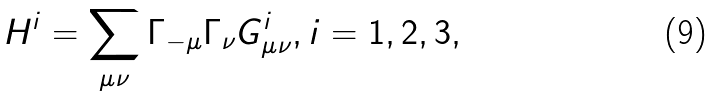Convert formula to latex. <formula><loc_0><loc_0><loc_500><loc_500>H ^ { i } = \sum _ { \mu \nu } \Gamma _ { - \mu } \Gamma _ { \nu } G ^ { i } _ { \mu \nu } , i = 1 , 2 , 3 ,</formula> 